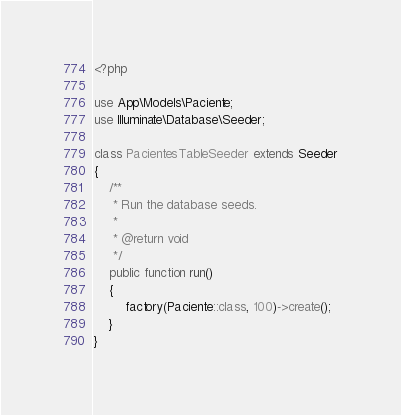Convert code to text. <code><loc_0><loc_0><loc_500><loc_500><_PHP_><?php

use App\Models\Paciente;
use Illuminate\Database\Seeder;

class PacientesTableSeeder extends Seeder
{
    /**
     * Run the database seeds.
     *
     * @return void
     */
    public function run()
    {
        factory(Paciente::class, 100)->create();
    }
}
</code> 